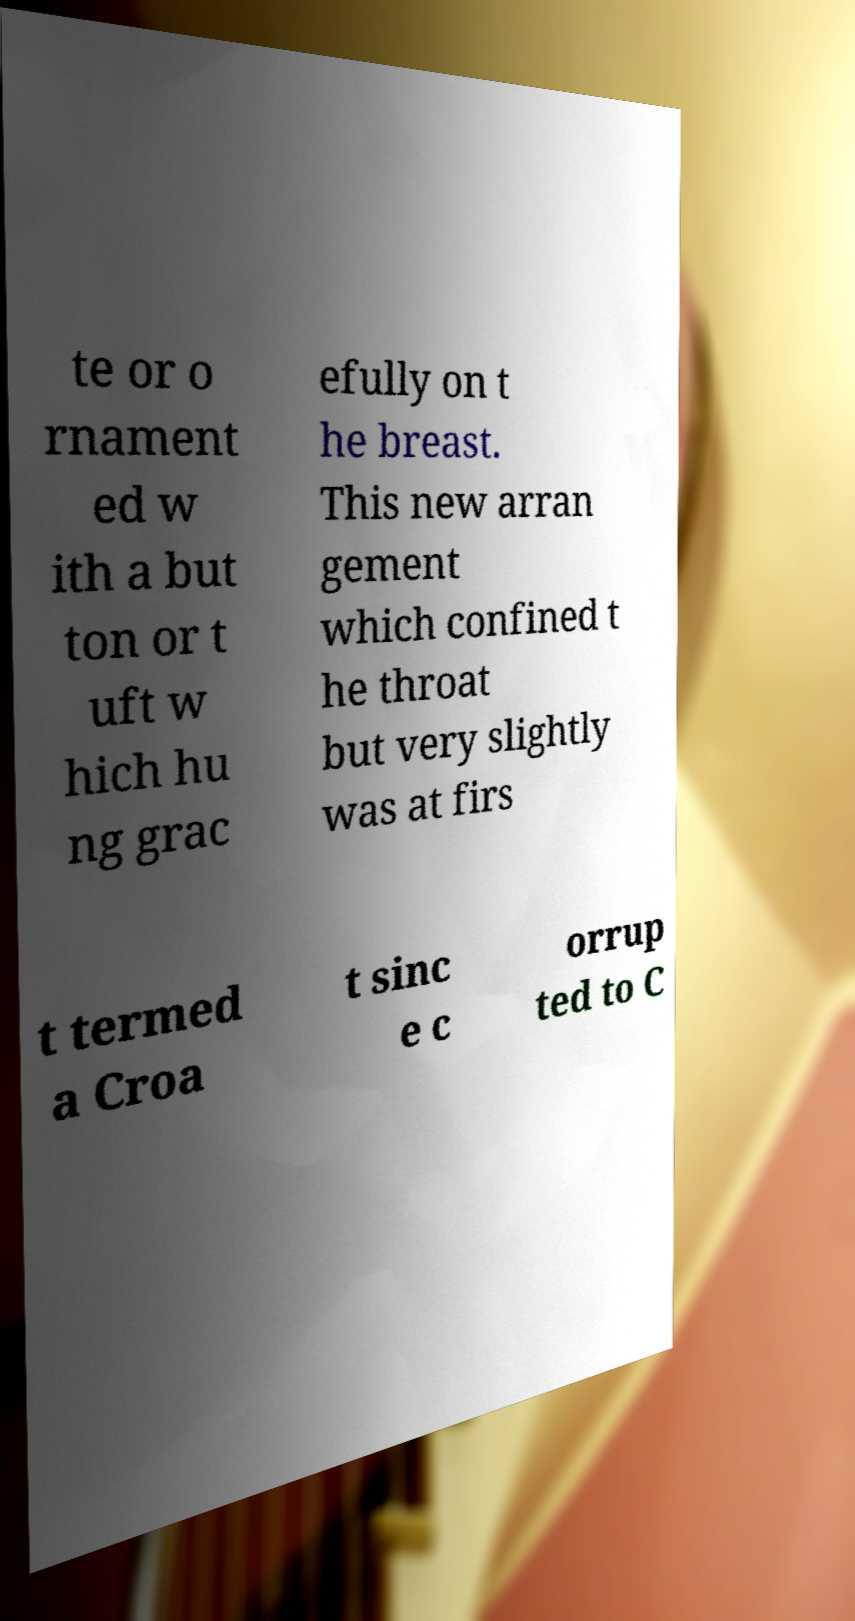There's text embedded in this image that I need extracted. Can you transcribe it verbatim? te or o rnament ed w ith a but ton or t uft w hich hu ng grac efully on t he breast. This new arran gement which confined t he throat but very slightly was at firs t termed a Croa t sinc e c orrup ted to C 